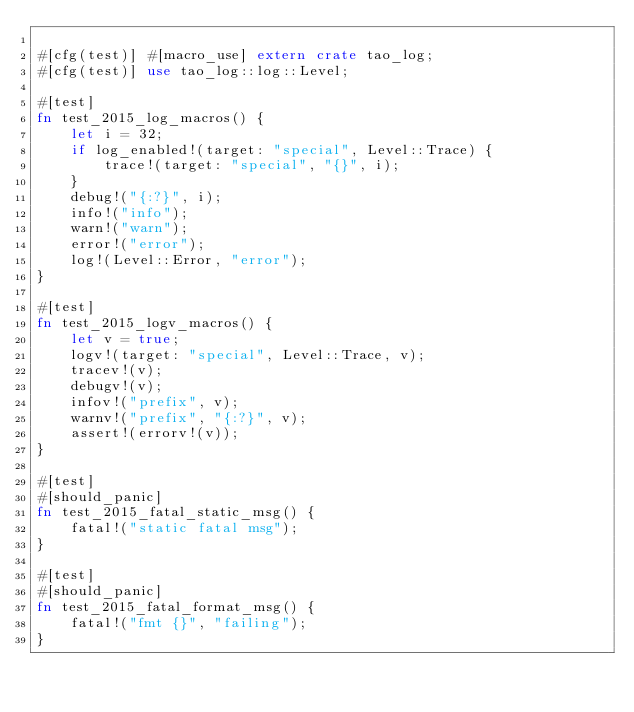<code> <loc_0><loc_0><loc_500><loc_500><_Rust_>
#[cfg(test)] #[macro_use] extern crate tao_log;
#[cfg(test)] use tao_log::log::Level;

#[test]
fn test_2015_log_macros() {
    let i = 32;
    if log_enabled!(target: "special", Level::Trace) {
        trace!(target: "special", "{}", i);
    }
    debug!("{:?}", i);
    info!("info");
    warn!("warn");
    error!("error");
    log!(Level::Error, "error");
}

#[test]
fn test_2015_logv_macros() {
    let v = true;
    logv!(target: "special", Level::Trace, v);
    tracev!(v);
    debugv!(v);
    infov!("prefix", v);
    warnv!("prefix", "{:?}", v);
    assert!(errorv!(v));
}

#[test]
#[should_panic]
fn test_2015_fatal_static_msg() {
    fatal!("static fatal msg");
}

#[test]
#[should_panic]
fn test_2015_fatal_format_msg() {
    fatal!("fmt {}", "failing");
}
</code> 